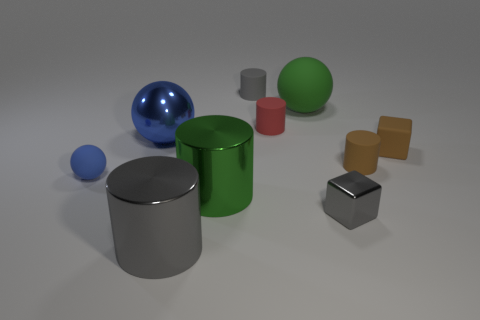Subtract 2 cylinders. How many cylinders are left? 3 Subtract all purple cylinders. Subtract all brown blocks. How many cylinders are left? 5 Subtract all cubes. How many objects are left? 8 Subtract 0 brown balls. How many objects are left? 10 Subtract all big matte balls. Subtract all small matte things. How many objects are left? 4 Add 6 metal things. How many metal things are left? 10 Add 9 gray matte objects. How many gray matte objects exist? 10 